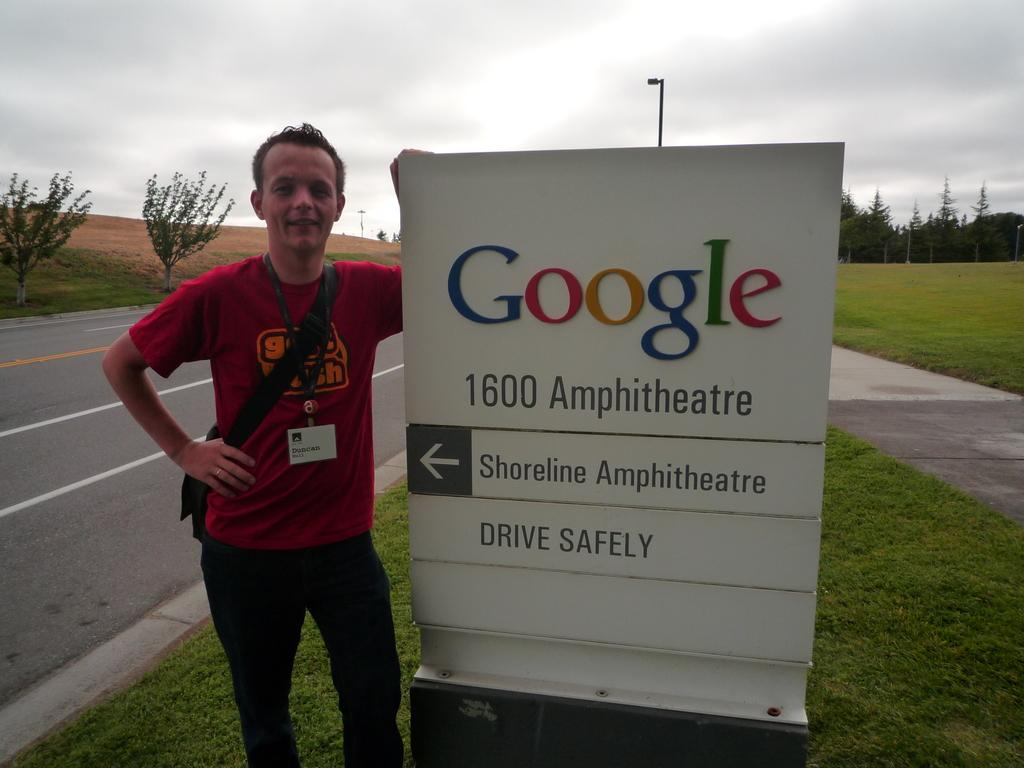<image>
Provide a brief description of the given image. A man called Duncan poses next to a sign telling us Google has its HQ here and asks us to drive safely. 